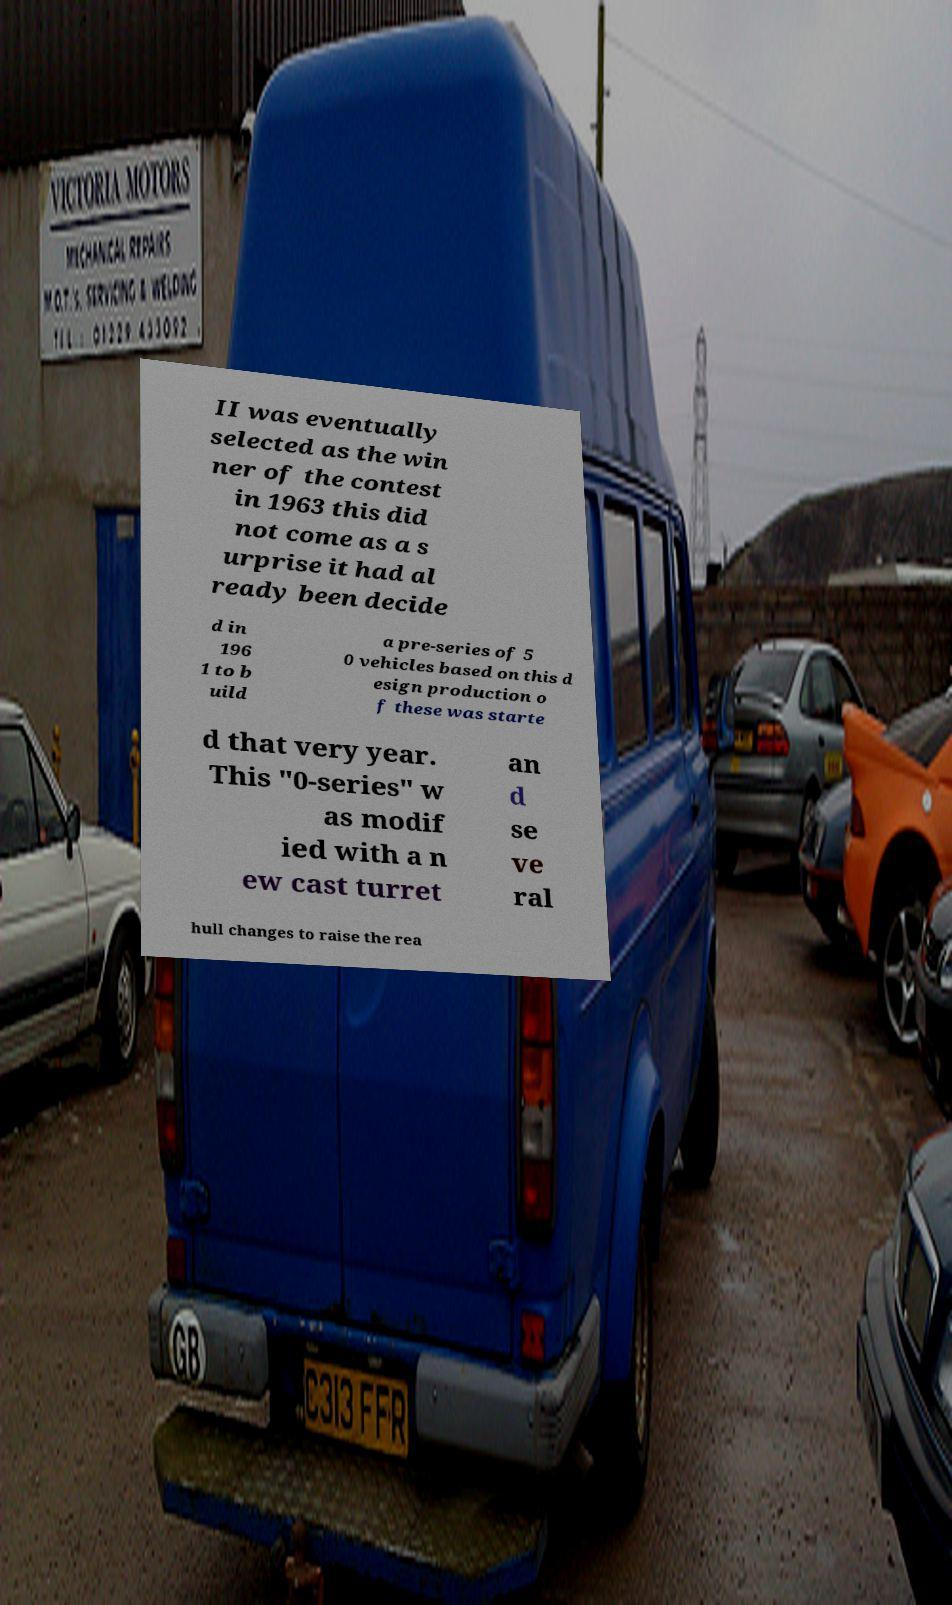What messages or text are displayed in this image? I need them in a readable, typed format. II was eventually selected as the win ner of the contest in 1963 this did not come as a s urprise it had al ready been decide d in 196 1 to b uild a pre-series of 5 0 vehicles based on this d esign production o f these was starte d that very year. This "0-series" w as modif ied with a n ew cast turret an d se ve ral hull changes to raise the rea 